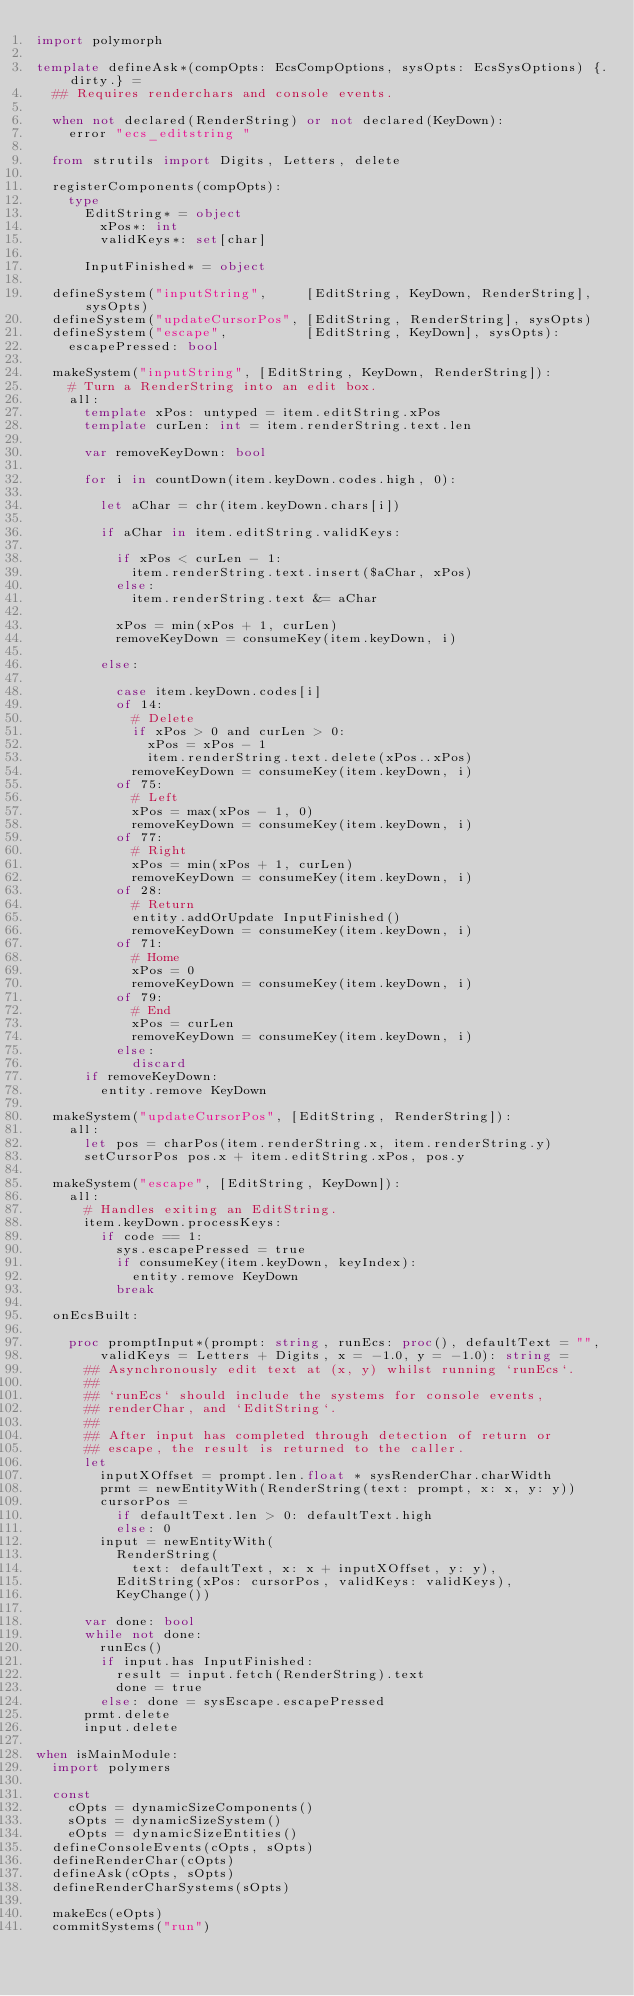<code> <loc_0><loc_0><loc_500><loc_500><_Nim_>import polymorph

template defineAsk*(compOpts: EcsCompOptions, sysOpts: EcsSysOptions) {.dirty.} =
  ## Requires renderchars and console events.
  
  when not declared(RenderString) or not declared(KeyDown):
    error "ecs_editstring "

  from strutils import Digits, Letters, delete

  registerComponents(compOpts):
    type
      EditString* = object
        xPos*: int
        validKeys*: set[char]

      InputFinished* = object

  defineSystem("inputString",     [EditString, KeyDown, RenderString], sysOpts)
  defineSystem("updateCursorPos", [EditString, RenderString], sysOpts)
  defineSystem("escape",          [EditString, KeyDown], sysOpts):
    escapePressed: bool

  makeSystem("inputString", [EditString, KeyDown, RenderString]):
    # Turn a RenderString into an edit box.
    all:
      template xPos: untyped = item.editString.xPos
      template curLen: int = item.renderString.text.len

      var removeKeyDown: bool

      for i in countDown(item.keyDown.codes.high, 0):

        let aChar = chr(item.keyDown.chars[i])

        if aChar in item.editString.validKeys:

          if xPos < curLen - 1:
            item.renderString.text.insert($aChar, xPos)
          else:
            item.renderString.text &= aChar

          xPos = min(xPos + 1, curLen)
          removeKeyDown = consumeKey(item.keyDown, i)

        else:

          case item.keyDown.codes[i]
          of 14:
            # Delete
            if xPos > 0 and curLen > 0:
              xPos = xPos - 1
              item.renderString.text.delete(xPos..xPos)
            removeKeyDown = consumeKey(item.keyDown, i)
          of 75:
            # Left
            xPos = max(xPos - 1, 0)
            removeKeyDown = consumeKey(item.keyDown, i)
          of 77:
            # Right
            xPos = min(xPos + 1, curLen)
            removeKeyDown = consumeKey(item.keyDown, i)
          of 28:
            # Return
            entity.addOrUpdate InputFinished()
            removeKeyDown = consumeKey(item.keyDown, i)
          of 71:
            # Home
            xPos = 0
            removeKeyDown = consumeKey(item.keyDown, i)
          of 79:
            # End
            xPos = curLen
            removeKeyDown = consumeKey(item.keyDown, i)
          else:
            discard
      if removeKeyDown:
        entity.remove KeyDown

  makeSystem("updateCursorPos", [EditString, RenderString]):
    all:
      let pos = charPos(item.renderString.x, item.renderString.y)
      setCursorPos pos.x + item.editString.xPos, pos.y

  makeSystem("escape", [EditString, KeyDown]):
    all:
      # Handles exiting an EditString.
      item.keyDown.processKeys:
        if code == 1:
          sys.escapePressed = true
          if consumeKey(item.keyDown, keyIndex):
            entity.remove KeyDown
          break

  onEcsBuilt:

    proc promptInput*(prompt: string, runEcs: proc(), defaultText = "",
        validKeys = Letters + Digits, x = -1.0, y = -1.0): string =
      ## Asynchronously edit text at (x, y) whilst running `runEcs`.
      ## 
      ## `runEcs` should include the systems for console events,
      ## renderChar, and `EditString`.
      ## 
      ## After input has completed through detection of return or
      ## escape, the result is returned to the caller.
      let
        inputXOffset = prompt.len.float * sysRenderChar.charWidth
        prmt = newEntityWith(RenderString(text: prompt, x: x, y: y))
        cursorPos =
          if defaultText.len > 0: defaultText.high
          else: 0
        input = newEntityWith(
          RenderString(
            text: defaultText, x: x + inputXOffset, y: y),
          EditString(xPos: cursorPos, validKeys: validKeys),
          KeyChange())

      var done: bool
      while not done:
        runEcs()
        if input.has InputFinished:
          result = input.fetch(RenderString).text
          done = true
        else: done = sysEscape.escapePressed
      prmt.delete
      input.delete    

when isMainModule:
  import polymers

  const
    cOpts = dynamicSizeComponents()
    sOpts = dynamicSizeSystem()
    eOpts = dynamicSizeEntities()
  defineConsoleEvents(cOpts, sOpts)
  defineRenderChar(cOpts)
  defineAsk(cOpts, sOpts)
  defineRenderCharSystems(sOpts)
  
  makeEcs(eOpts)
  commitSystems("run")
</code> 